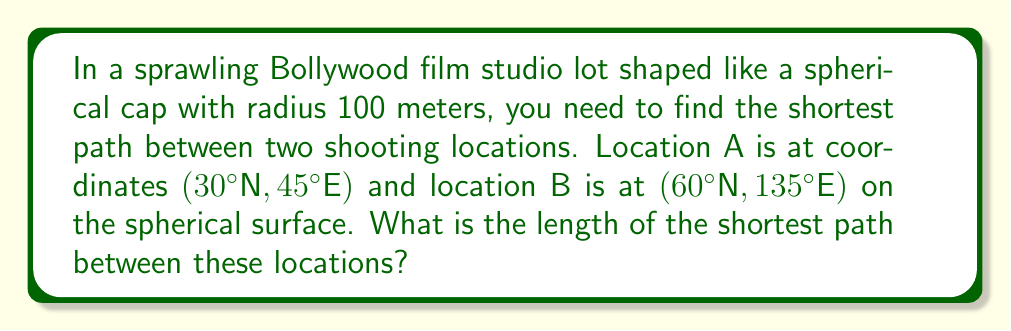Show me your answer to this math problem. To solve this problem, we'll use concepts from spherical geometry:

1. First, we need to calculate the central angle $\theta$ between the two points using the spherical law of cosines:

   $$\cos(\theta) = \sin(\phi_1)\sin(\phi_2) + \cos(\phi_1)\cos(\phi_2)\cos(\Delta\lambda)$$

   Where $\phi_1$ and $\phi_2$ are the latitudes, and $\Delta\lambda$ is the difference in longitudes.

2. Plugging in our values:
   $\phi_1 = 30°$, $\phi_2 = 60°$, $\Delta\lambda = 135° - 45° = 90°$

   $$\cos(\theta) = \sin(30°)\sin(60°) + \cos(30°)\cos(60°)\cos(90°)$$

3. Calculating:
   $$\cos(\theta) = (0.5)(0.866) + (0.866)(0.5)(0) = 0.433$$

4. Taking the inverse cosine:
   $$\theta = \arccos(0.433) \approx 1.124 \text{ radians} \approx 64.4°$$

5. Now that we have the central angle, we can calculate the length of the geodesic (shortest path) using the arc length formula:

   $$s = R\theta$$

   Where $R$ is the radius of the sphere (100 meters) and $\theta$ is in radians.

6. Calculating the length:
   $$s = 100 * 1.124 \approx 112.4 \text{ meters}$$

[asy]
import geometry;

size(200);
pair O=(0,0);
real R=100;
draw(circle(O,R));
pair A=R*dir(45);
pair B=R*dir(135);
draw(A--O--B,dashed);
draw(Arc(O,A,B),linewidth(2));
label("A",A,E);
label("B",B,NE);
label("O",O,SW);
</asy]
Answer: 112.4 meters 